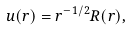Convert formula to latex. <formula><loc_0><loc_0><loc_500><loc_500>u ( r ) = r ^ { - 1 / 2 } R ( r ) ,</formula> 